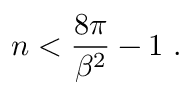Convert formula to latex. <formula><loc_0><loc_0><loc_500><loc_500>n < { \frac { 8 \pi } { \beta ^ { 2 } } } - 1 \, .</formula> 